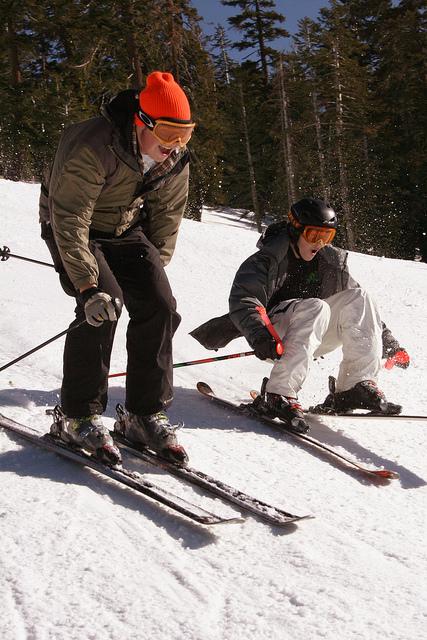What season is it?
Answer briefly. Winter. Are they playing poker?
Keep it brief. No. What is the orange hat made of?
Give a very brief answer. Wool. 